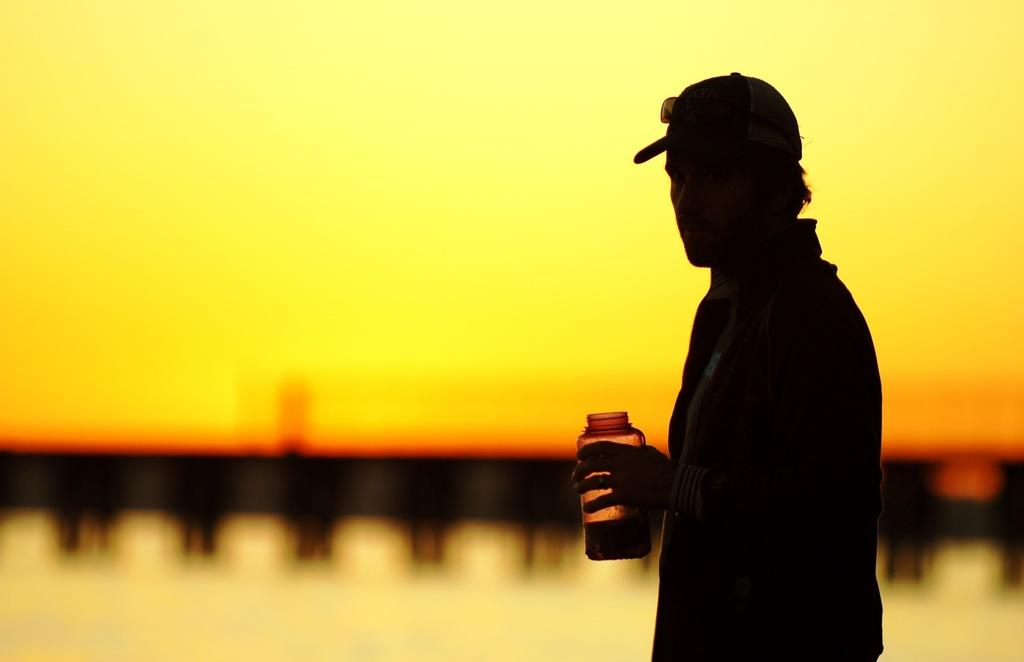What can be seen in the image? There is a person in the image. What type of clothing is the person wearing? The person is wearing a jacket, a cap, and goggles. What is the person holding in their hands? The person is holding a bottle in their hands. Can you describe the background of the image? The background of the image is blurry. How many babies are visible in the image? There are no babies present in the image. What type of apparatus is the person using to communicate with their brother? There is no apparatus visible in the image, and there is no mention of a brother. 